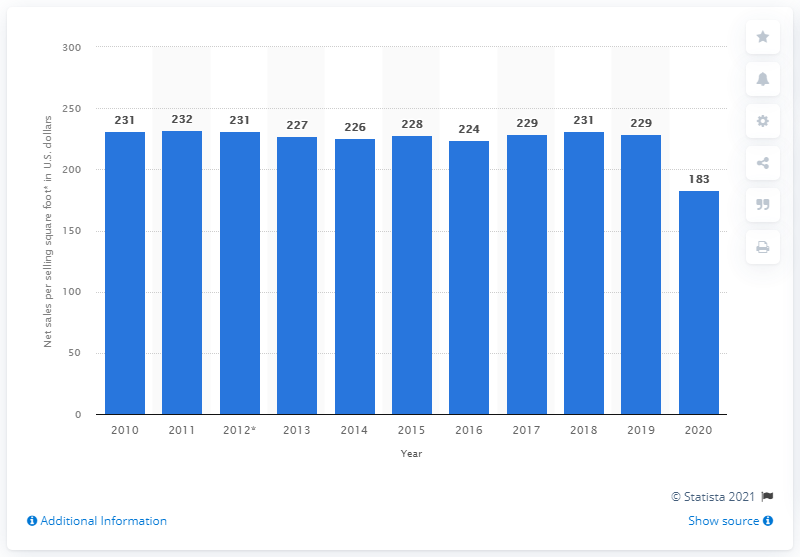Highlight a few significant elements in this photo. In 2020, Kohl's Corporation generated an average of $183 in sales per selling square foot. Kohl's Corporation generated $229 in revenue per selling square foot in the previous year. 